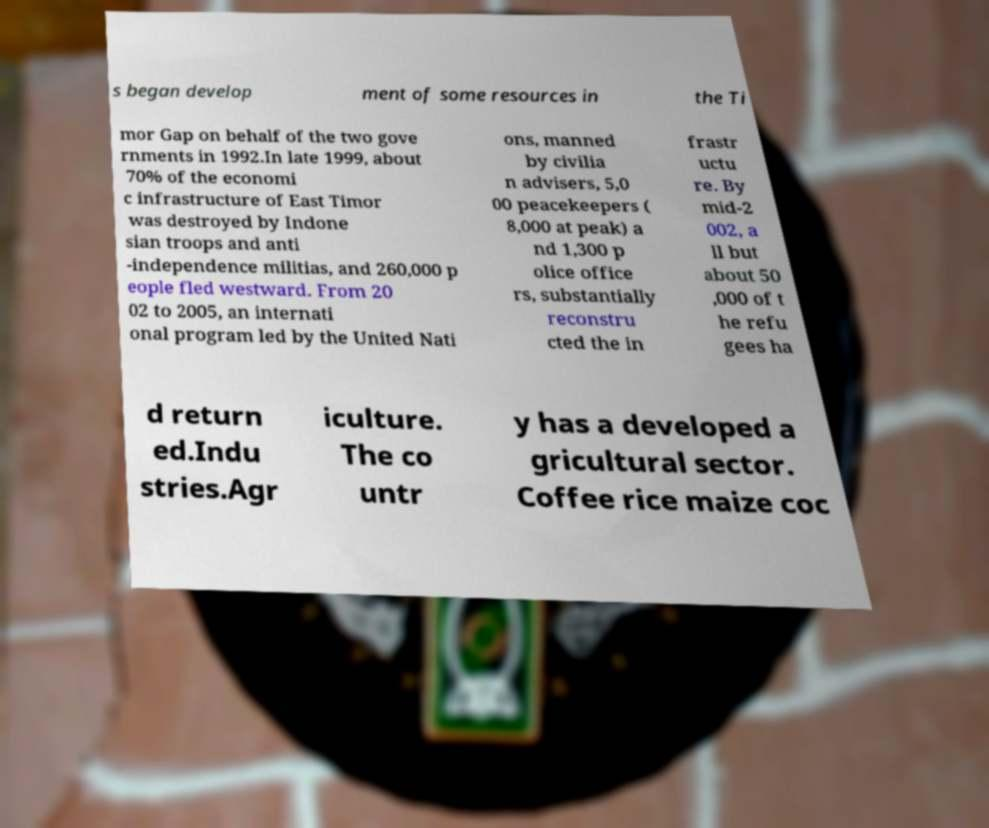Can you accurately transcribe the text from the provided image for me? s began develop ment of some resources in the Ti mor Gap on behalf of the two gove rnments in 1992.In late 1999, about 70% of the economi c infrastructure of East Timor was destroyed by Indone sian troops and anti -independence militias, and 260,000 p eople fled westward. From 20 02 to 2005, an internati onal program led by the United Nati ons, manned by civilia n advisers, 5,0 00 peacekeepers ( 8,000 at peak) a nd 1,300 p olice office rs, substantially reconstru cted the in frastr uctu re. By mid-2 002, a ll but about 50 ,000 of t he refu gees ha d return ed.Indu stries.Agr iculture. The co untr y has a developed a gricultural sector. Coffee rice maize coc 